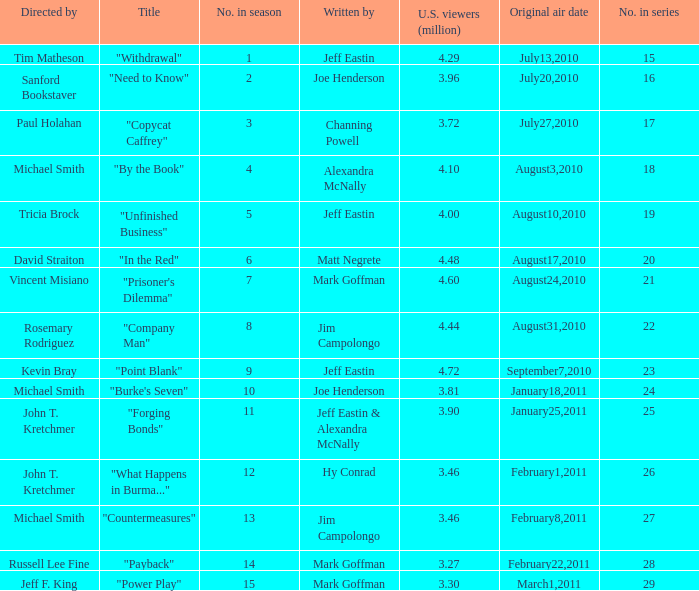How many millions of people in the US watched the "Company Man" episode? 4.44. 